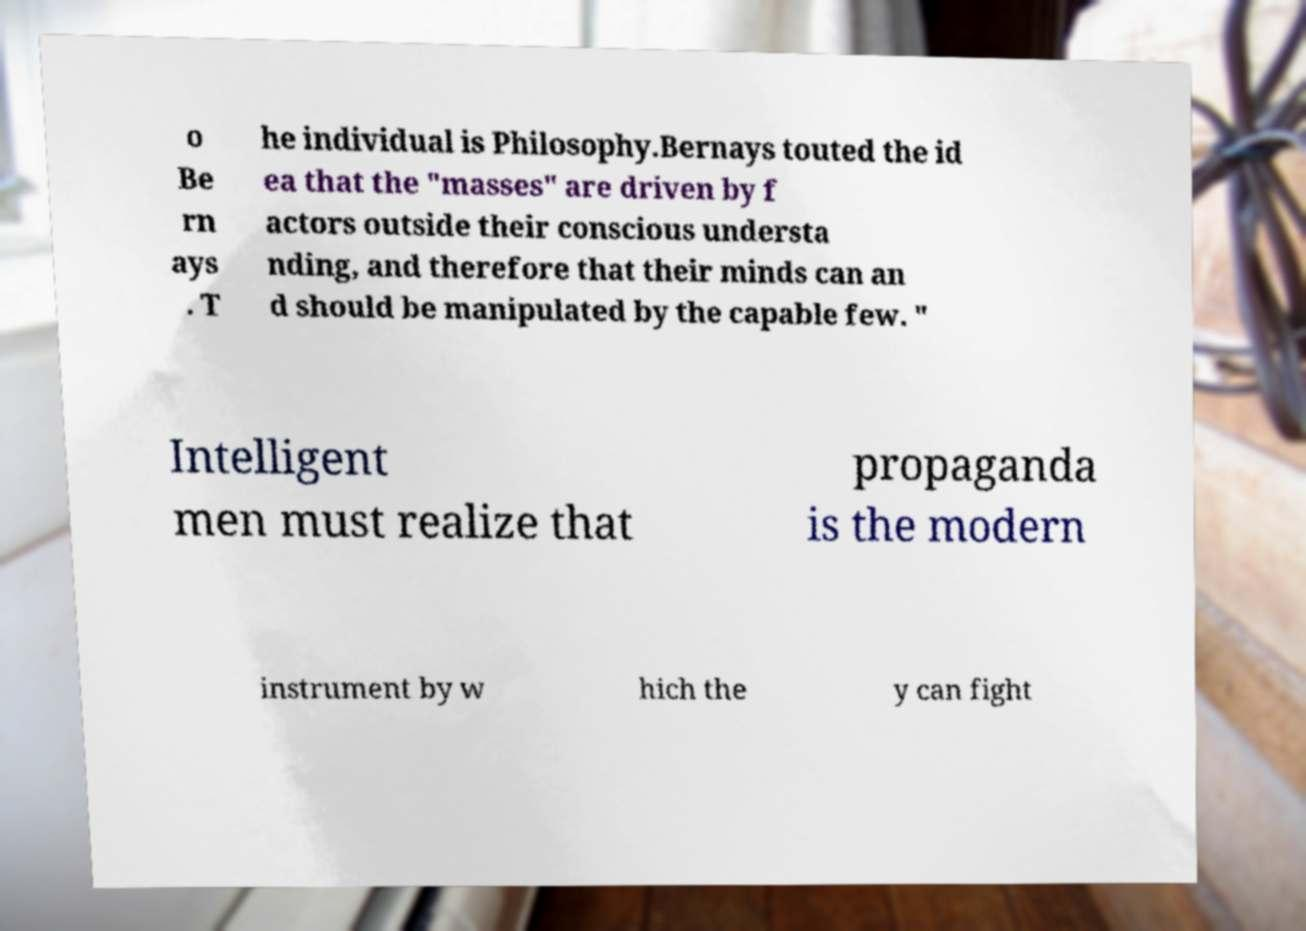I need the written content from this picture converted into text. Can you do that? o Be rn ays . T he individual is Philosophy.Bernays touted the id ea that the "masses" are driven by f actors outside their conscious understa nding, and therefore that their minds can an d should be manipulated by the capable few. " Intelligent men must realize that propaganda is the modern instrument by w hich the y can fight 